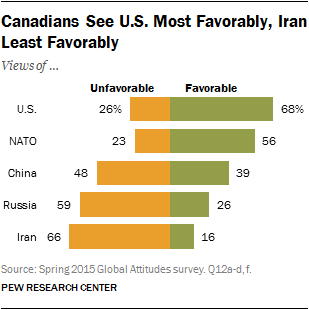Outline some significant characteristics in this image. Only two countries have a favorable rating of over 50%. According to a recent survey, 68% of people view the United States favorably. 